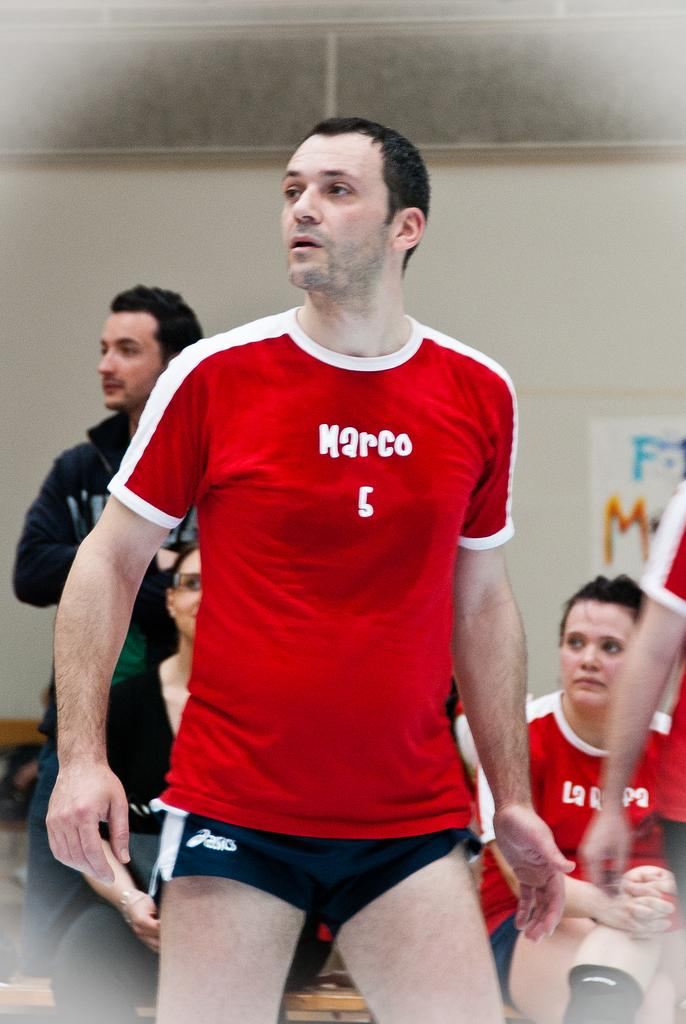<image>
Provide a brief description of the given image. Man wearing a red shirt which says marco on it. 